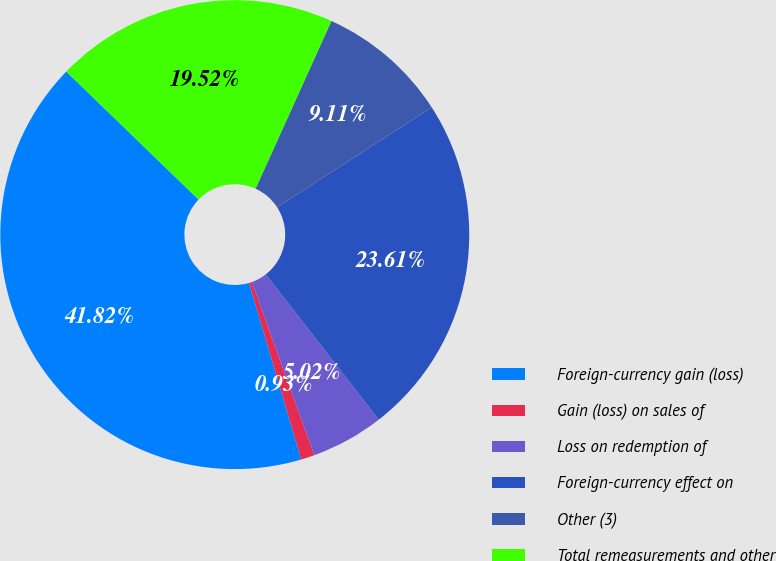<chart> <loc_0><loc_0><loc_500><loc_500><pie_chart><fcel>Foreign-currency gain (loss)<fcel>Gain (loss) on sales of<fcel>Loss on redemption of<fcel>Foreign-currency effect on<fcel>Other (3)<fcel>Total remeasurements and other<nl><fcel>41.82%<fcel>0.93%<fcel>5.02%<fcel>23.61%<fcel>9.11%<fcel>19.52%<nl></chart> 